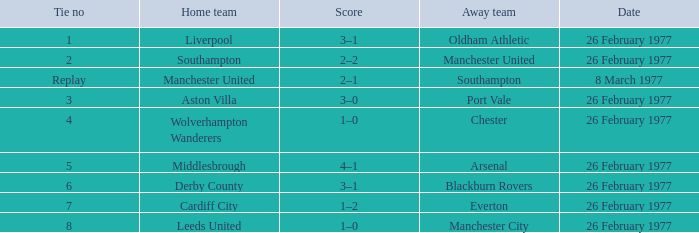Against manchester united, who was the host team? Southampton. 